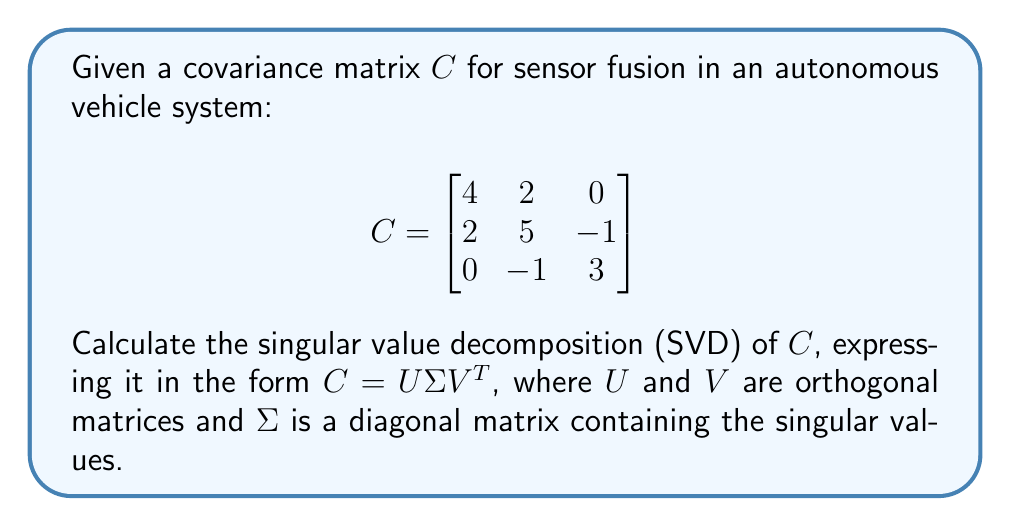Show me your answer to this math problem. To calculate the singular value decomposition of the covariance matrix $C$, we'll follow these steps:

1) First, note that for a symmetric matrix like $C$, the SVD is equivalent to the eigendecomposition. The singular values are the absolute values of the eigenvalues, and the left and right singular vectors (columns of $U$ and $V$) are the same as the eigenvectors.

2) Calculate the eigenvalues of $C$ by solving the characteristic equation:
   $$\det(C - \lambda I) = 0$$
   
   $$\begin{vmatrix}
   4-\lambda & 2 & 0 \\
   2 & 5-\lambda & -1 \\
   0 & -1 & 3-\lambda
   \end{vmatrix} = 0$$

3) Expanding this determinant yields:
   $$(4-\lambda)(5-\lambda)(3-\lambda) - 2^2(3-\lambda) - (-1)^2(4-\lambda) = 0$$
   $$(4-\lambda)(5-\lambda)(3-\lambda) - 4(3-\lambda) - (4-\lambda) = 0$$
   $$\lambda^3 - 12\lambda^2 + 41\lambda - 36 = 0$$

4) Solving this cubic equation (using a computer algebra system or numerical methods) gives the eigenvalues:
   $$\lambda_1 \approx 7.5358, \lambda_2 \approx 3.3165, \lambda_3 \approx 1.1477$$

5) For each eigenvalue, find the corresponding eigenvector by solving $(C - \lambda_i I)v_i = 0$:

   For $\lambda_1 \approx 7.5358$:
   $$v_1 \approx [-0.4376, -0.7728, 0.4597]^T$$

   For $\lambda_2 \approx 3.3165$:
   $$v_2 \approx [-0.6364, 0.0954, -0.7655]^T$$

   For $\lambda_3 \approx 1.1477$:
   $$v_3 \approx [-0.6339, 0.6284, 0.4509]^T$$

6) Normalize these eigenvectors to unit length. They form the columns of $U$ and $V$:

   $$U = V = \begin{bmatrix}
   -0.4376 & -0.6364 & -0.6339 \\
   -0.7728 & 0.0954 & 0.6284 \\
   0.4597 & -0.7655 & 0.4509
   \end{bmatrix}$$

7) The singular values are the square roots of the eigenvalues, which form the diagonal entries of $\Sigma$:

   $$\Sigma = \begin{bmatrix}
   \sqrt{7.5358} & 0 & 0 \\
   0 & \sqrt{3.3165} & 0 \\
   0 & 0 & \sqrt{1.1477}
   \end{bmatrix} \approx \begin{bmatrix}
   2.7452 & 0 & 0 \\
   0 & 1.8211 & 0 \\
   0 & 0 & 1.0713
   \end{bmatrix}$$

Thus, we have obtained the singular value decomposition $C = U\Sigma V^T$.
Answer: $C = U\Sigma V^T$, where:

$$U = V \approx \begin{bmatrix}
-0.4376 & -0.6364 & -0.6339 \\
-0.7728 & 0.0954 & 0.6284 \\
0.4597 & -0.7655 & 0.4509
\end{bmatrix}$$

$$\Sigma \approx \begin{bmatrix}
2.7452 & 0 & 0 \\
0 & 1.8211 & 0 \\
0 & 0 & 1.0713
\end{bmatrix}$$ 